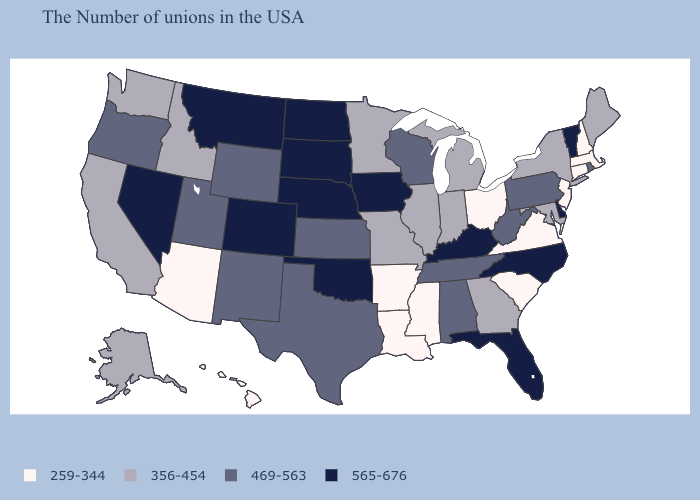Name the states that have a value in the range 356-454?
Quick response, please. Maine, New York, Maryland, Georgia, Michigan, Indiana, Illinois, Missouri, Minnesota, Idaho, California, Washington, Alaska. Among the states that border Missouri , does Oklahoma have the lowest value?
Give a very brief answer. No. What is the value of Virginia?
Concise answer only. 259-344. What is the value of Colorado?
Quick response, please. 565-676. Does New York have the lowest value in the Northeast?
Keep it brief. No. Does Oregon have the highest value in the West?
Be succinct. No. What is the value of West Virginia?
Give a very brief answer. 469-563. Name the states that have a value in the range 469-563?
Give a very brief answer. Rhode Island, Pennsylvania, West Virginia, Alabama, Tennessee, Wisconsin, Kansas, Texas, Wyoming, New Mexico, Utah, Oregon. Among the states that border Nevada , does Arizona have the highest value?
Concise answer only. No. What is the value of Louisiana?
Answer briefly. 259-344. What is the value of Maryland?
Answer briefly. 356-454. Name the states that have a value in the range 469-563?
Write a very short answer. Rhode Island, Pennsylvania, West Virginia, Alabama, Tennessee, Wisconsin, Kansas, Texas, Wyoming, New Mexico, Utah, Oregon. Does the first symbol in the legend represent the smallest category?
Short answer required. Yes. Does Kansas have the same value as Florida?
Answer briefly. No. Name the states that have a value in the range 356-454?
Short answer required. Maine, New York, Maryland, Georgia, Michigan, Indiana, Illinois, Missouri, Minnesota, Idaho, California, Washington, Alaska. 